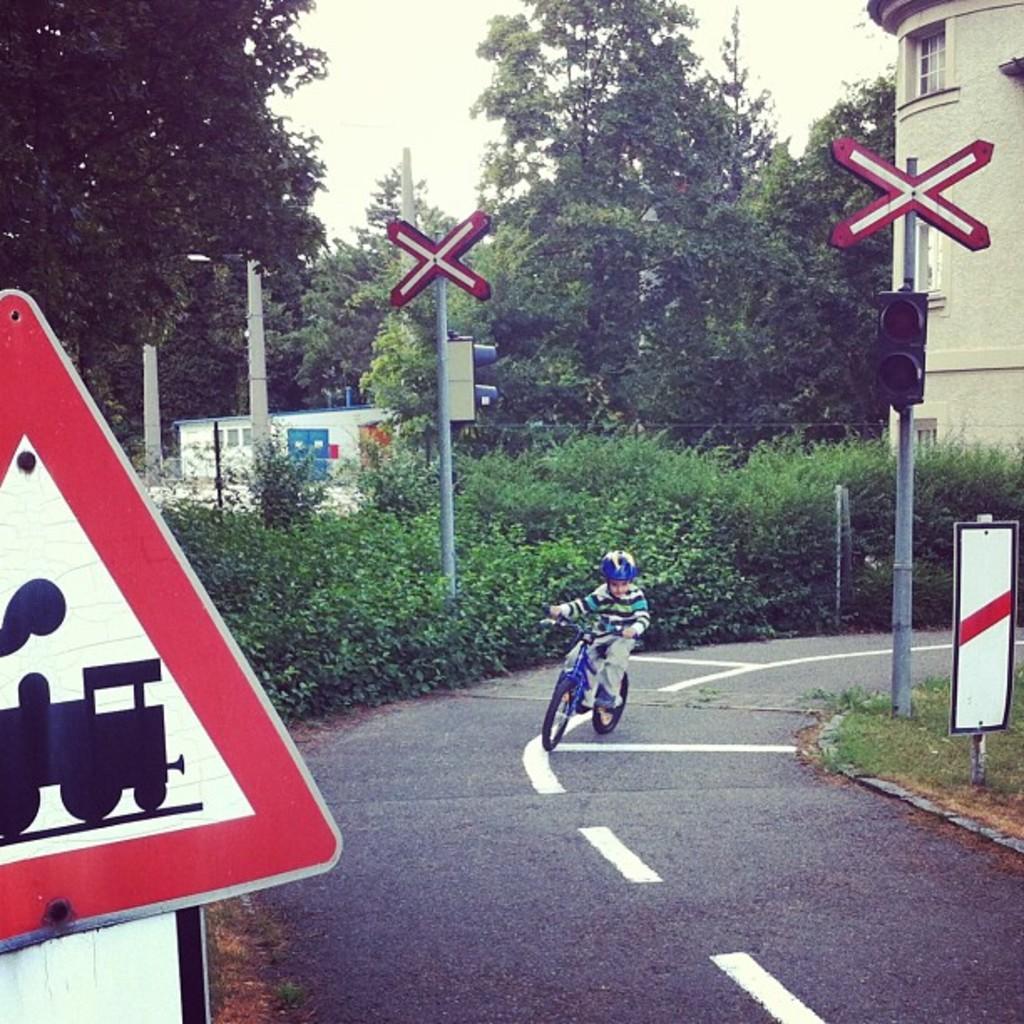In one or two sentences, can you explain what this image depicts? This is a boy riding a bicycle on the road. These are the trees and the bushes. I can see the sign boards and traffic lights, which are attached to the poles. On the right side of the image, I can see a building with a window. This looks like the grass. 